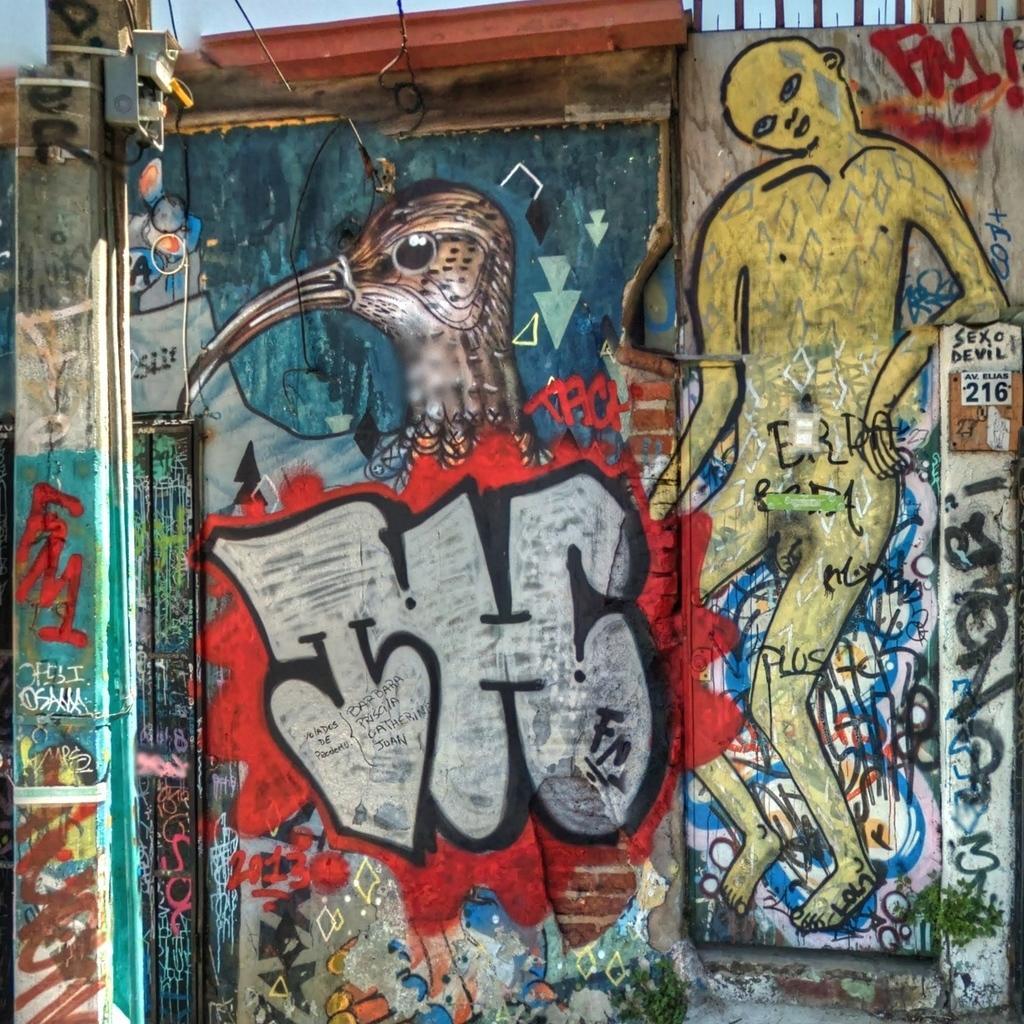Can you describe this image briefly? In this image there is a wall. There is a painting on the wall. We can see a bird and a human painting. There is a sky. 